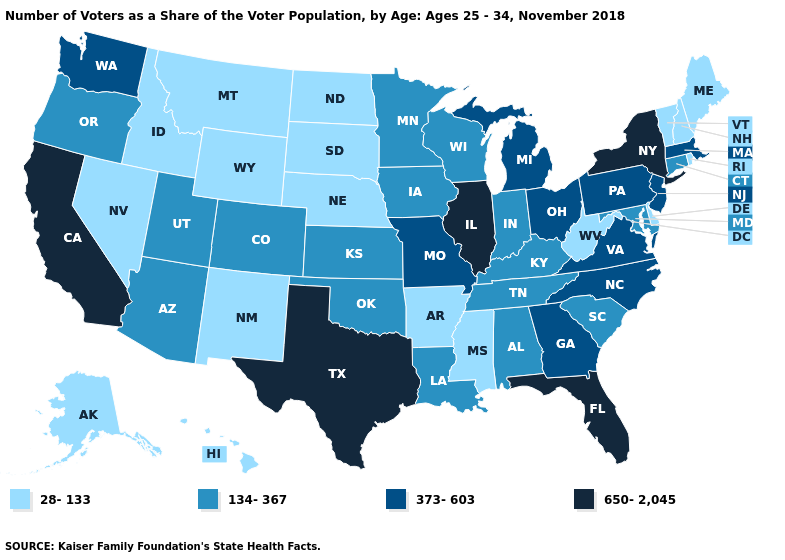Name the states that have a value in the range 650-2,045?
Short answer required. California, Florida, Illinois, New York, Texas. Name the states that have a value in the range 650-2,045?
Short answer required. California, Florida, Illinois, New York, Texas. Name the states that have a value in the range 650-2,045?
Quick response, please. California, Florida, Illinois, New York, Texas. Name the states that have a value in the range 134-367?
Write a very short answer. Alabama, Arizona, Colorado, Connecticut, Indiana, Iowa, Kansas, Kentucky, Louisiana, Maryland, Minnesota, Oklahoma, Oregon, South Carolina, Tennessee, Utah, Wisconsin. Does Illinois have the highest value in the MidWest?
Short answer required. Yes. Name the states that have a value in the range 650-2,045?
Write a very short answer. California, Florida, Illinois, New York, Texas. What is the lowest value in the USA?
Give a very brief answer. 28-133. Among the states that border Mississippi , does Arkansas have the lowest value?
Quick response, please. Yes. Among the states that border Kentucky , does Illinois have the highest value?
Be succinct. Yes. What is the lowest value in the MidWest?
Answer briefly. 28-133. Does the first symbol in the legend represent the smallest category?
Give a very brief answer. Yes. What is the value of Montana?
Keep it brief. 28-133. Which states have the lowest value in the Northeast?
Answer briefly. Maine, New Hampshire, Rhode Island, Vermont. Does Idaho have the lowest value in the West?
Be succinct. Yes. 